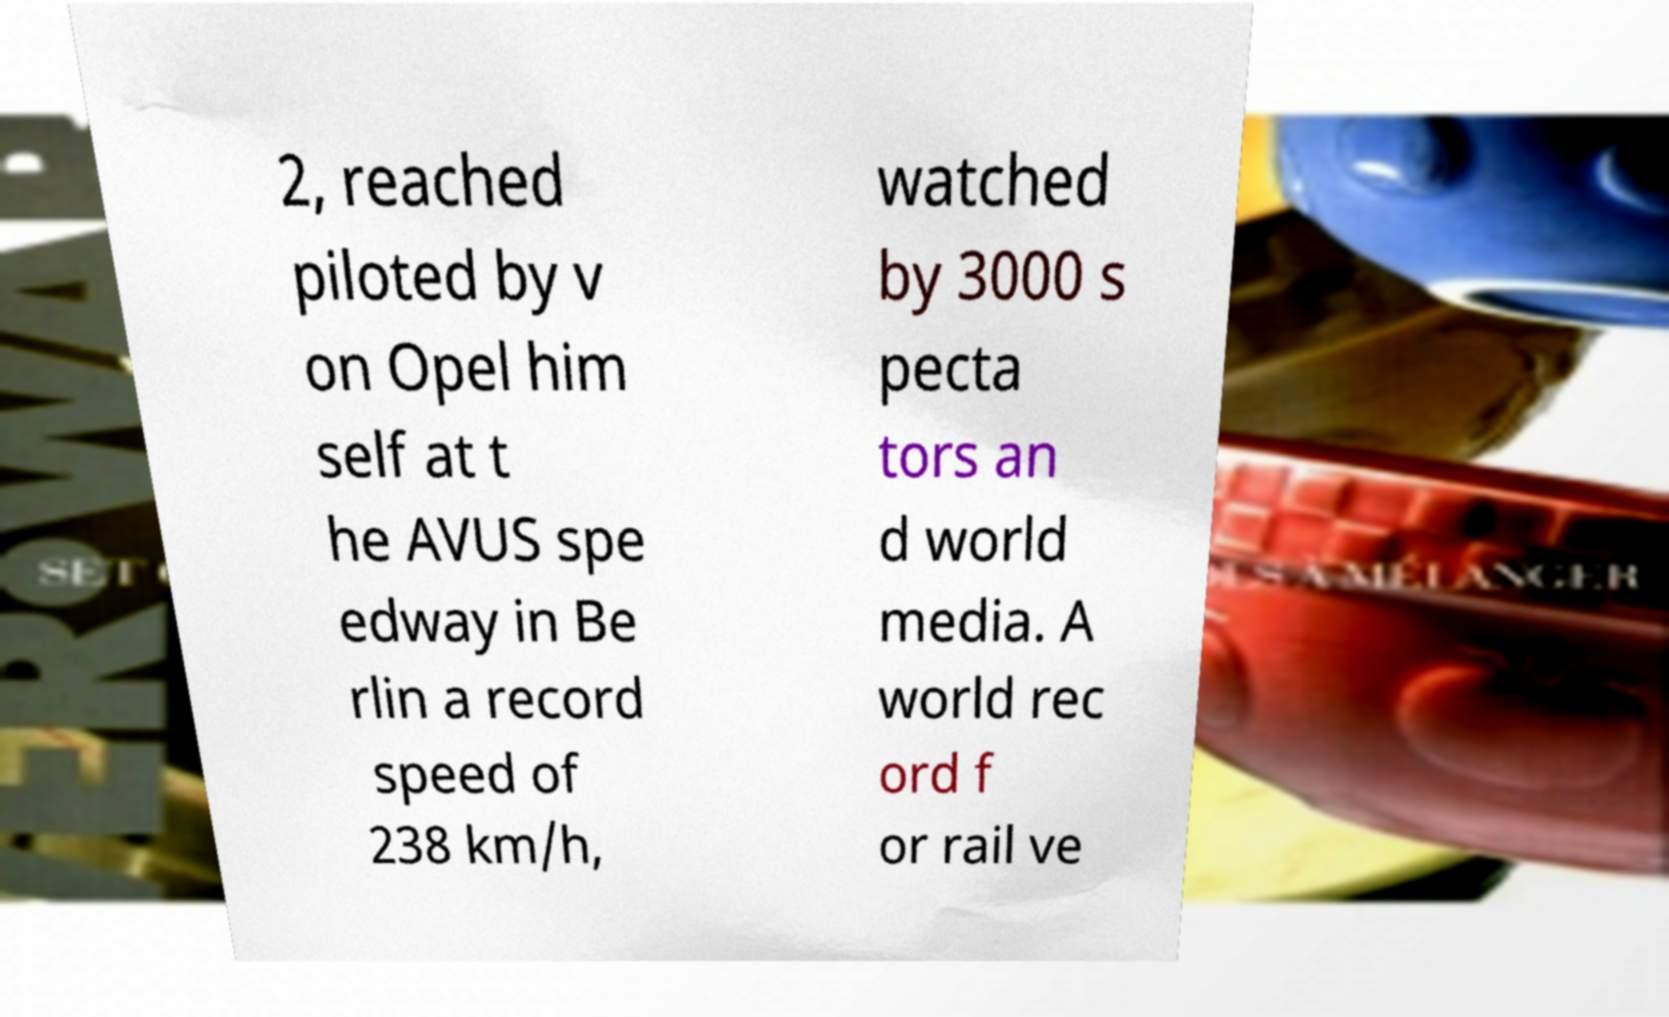Could you assist in decoding the text presented in this image and type it out clearly? 2, reached piloted by v on Opel him self at t he AVUS spe edway in Be rlin a record speed of 238 km/h, watched by 3000 s pecta tors an d world media. A world rec ord f or rail ve 